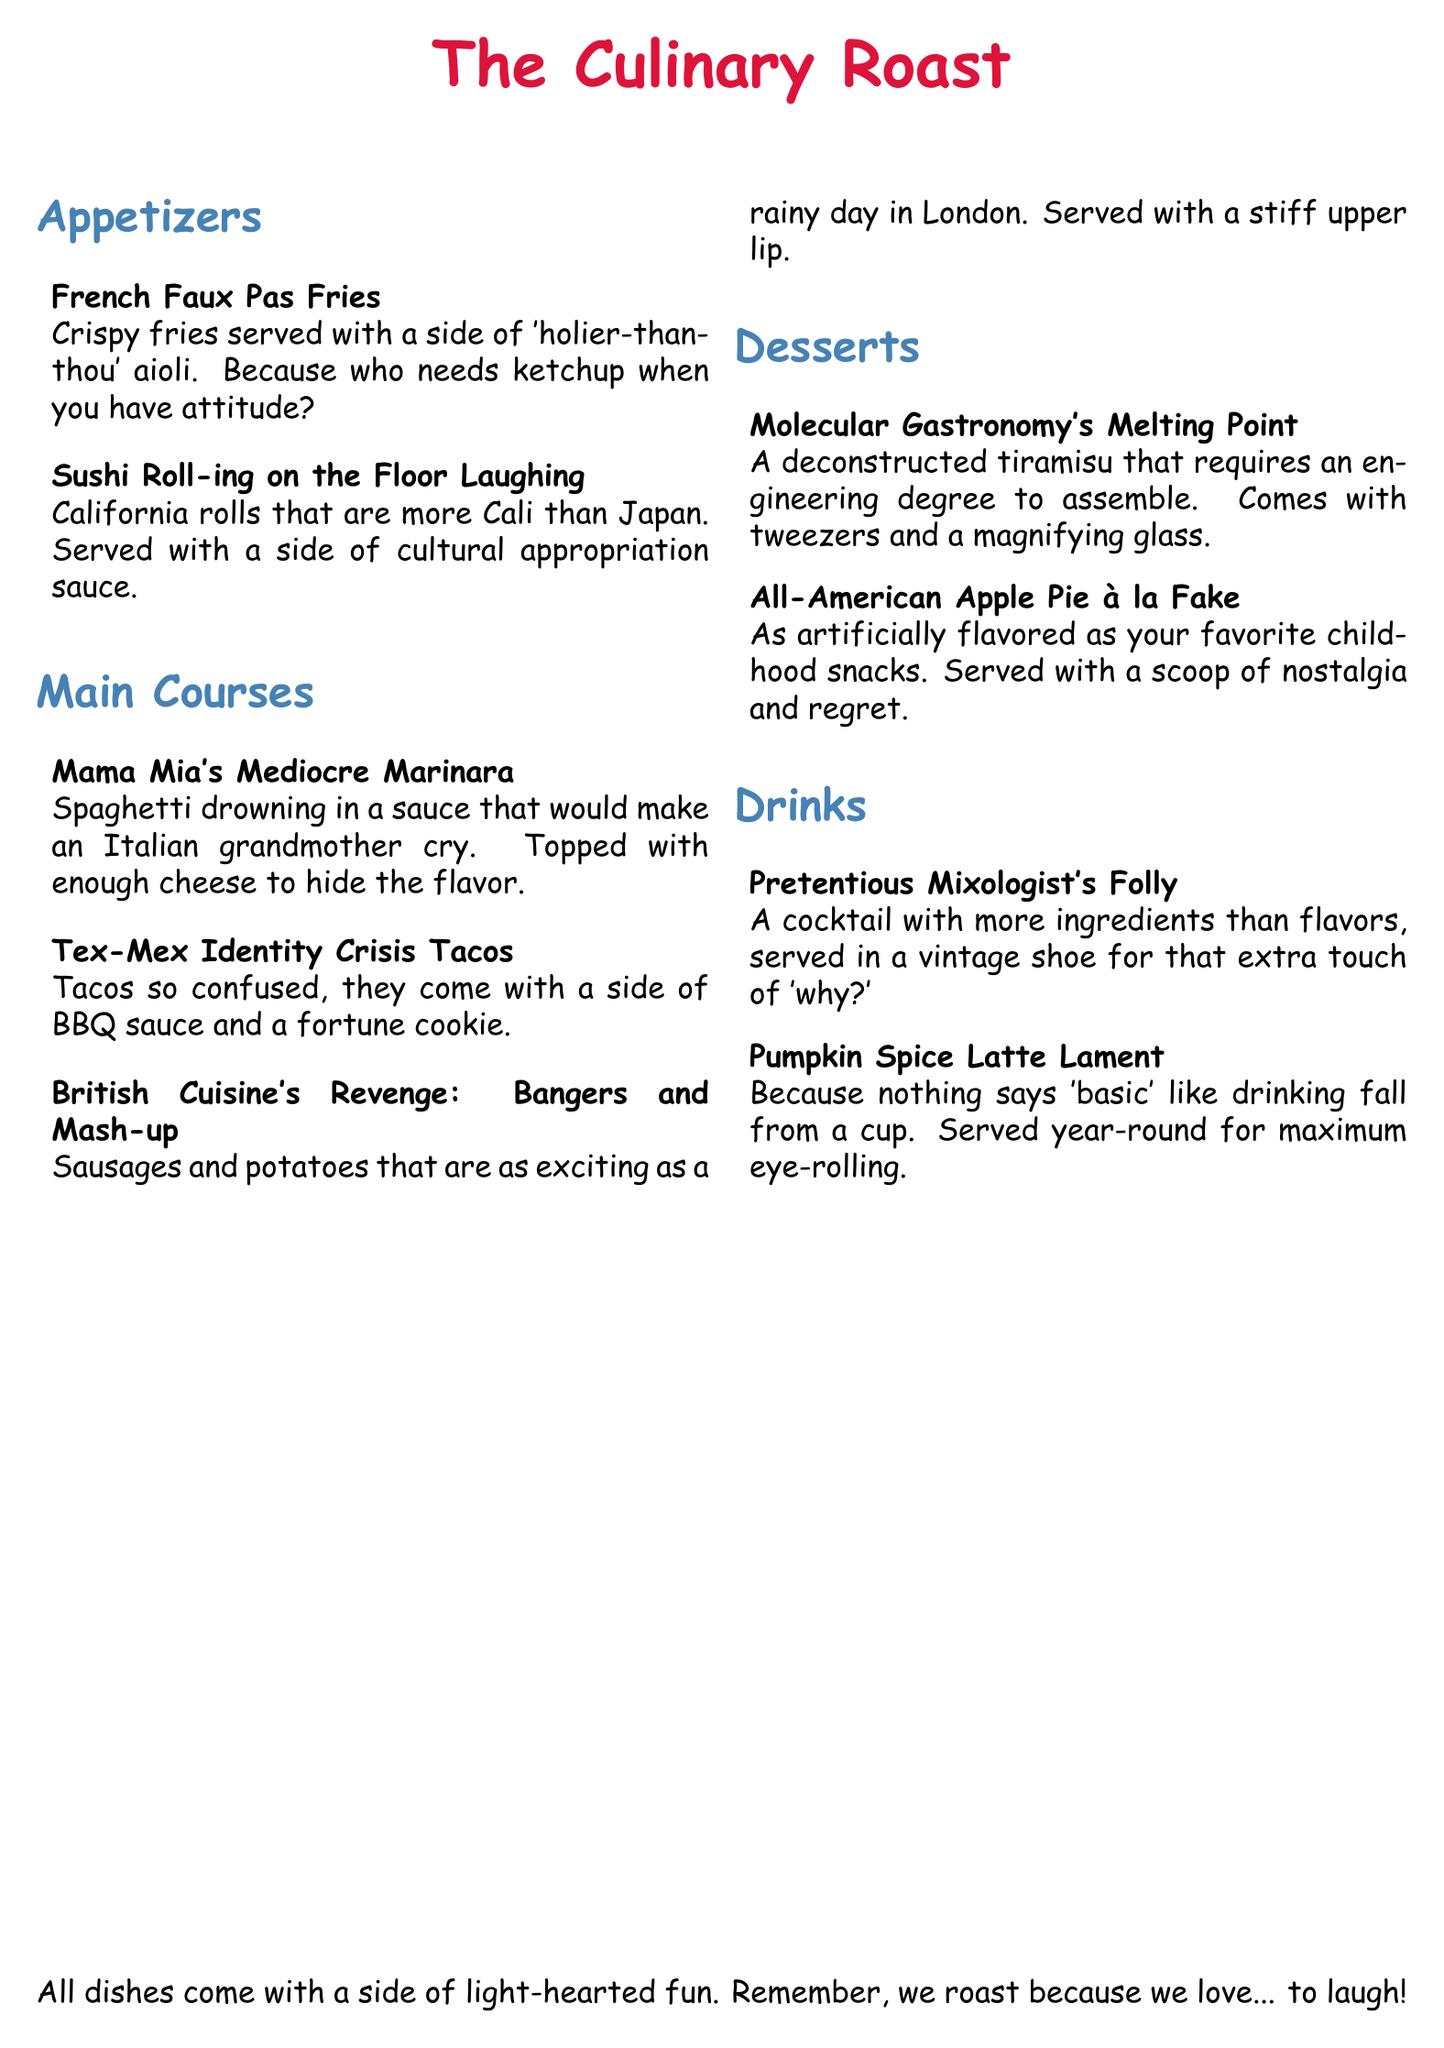What is the title of the menu? The title of the menu is prominently displayed at the top, indicating the theme of the document.
Answer: The Culinary Roast How many appetizers are listed? The document lists appetizers in a specific section, and counting them reveals the quantity.
Answer: 2 What dish is described with the phrase "as exciting as a rainy day in London"? The humor in the description provides a specific reference to one of the main courses.
Answer: British Cuisine's Revenge: Bangers and Mash-up What dessert requires an engineering degree to assemble? The document humorously describes a dessert that is complicated in nature.
Answer: Molecular Gastronomy's Melting Point Which drink is served year-round for maximum eye-rolling? This description indicates a humorous take on the drink's seasonal popularity.
Answer: Pumpkin Spice Latte Lament 